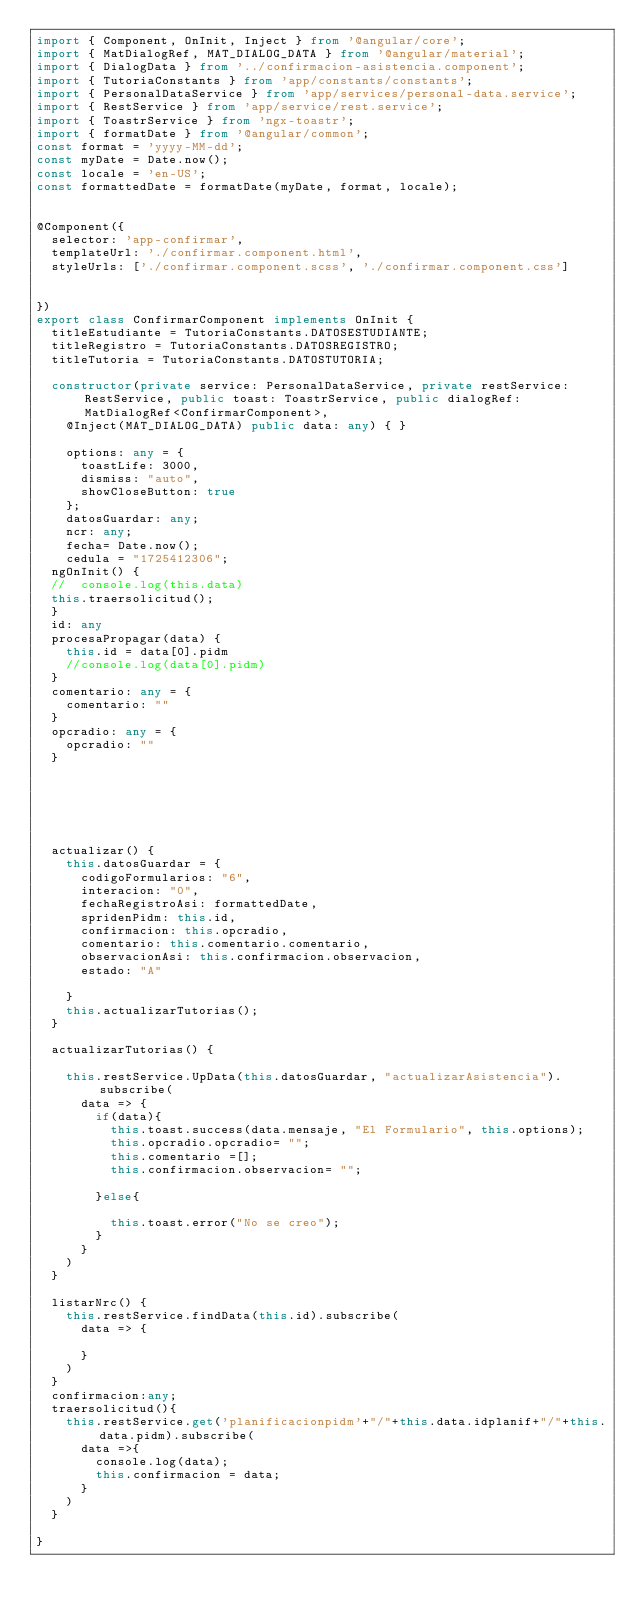Convert code to text. <code><loc_0><loc_0><loc_500><loc_500><_TypeScript_>import { Component, OnInit, Inject } from '@angular/core';
import { MatDialogRef, MAT_DIALOG_DATA } from '@angular/material';
import { DialogData } from '../confirmacion-asistencia.component';
import { TutoriaConstants } from 'app/constants/constants';
import { PersonalDataService } from 'app/services/personal-data.service';
import { RestService } from 'app/service/rest.service';
import { ToastrService } from 'ngx-toastr';
import { formatDate } from '@angular/common';
const format = 'yyyy-MM-dd';
const myDate = Date.now();
const locale = 'en-US';
const formattedDate = formatDate(myDate, format, locale);


@Component({
  selector: 'app-confirmar',
  templateUrl: './confirmar.component.html',
  styleUrls: ['./confirmar.component.scss', './confirmar.component.css']
  

})
export class ConfirmarComponent implements OnInit {
  titleEstudiante = TutoriaConstants.DATOSESTUDIANTE;
  titleRegistro = TutoriaConstants.DATOSREGISTRO;
  titleTutoria = TutoriaConstants.DATOSTUTORIA;

  constructor(private service: PersonalDataService, private restService: RestService, public toast: ToastrService, public dialogRef: MatDialogRef<ConfirmarComponent>,
    @Inject(MAT_DIALOG_DATA) public data: any) { }

    options: any = {
      toastLife: 3000,
      dismiss: "auto",
      showCloseButton: true
    };
    datosGuardar: any;
    ncr: any;
    fecha= Date.now();
    cedula = "1725412306";
  ngOnInit() {
  //  console.log(this.data)
  this.traersolicitud();
  }
  id: any
  procesaPropagar(data) {
    this.id = data[0].pidm
    //console.log(data[0].pidm)
  }
  comentario: any = {
    comentario: ""
  }
  opcradio: any = {
    opcradio: ""
  }



  


  actualizar() {
    this.datosGuardar = {
      codigoFormularios: "6",
      interacion: "0",
      fechaRegistroAsi: formattedDate,
      spridenPidm: this.id,
      confirmacion: this.opcradio,
      comentario: this.comentario.comentario,
      observacionAsi: this.confirmacion.observacion,
      estado: "A"

    }
    this.actualizarTutorias();
  }

  actualizarTutorias() {

    this.restService.UpData(this.datosGuardar, "actualizarAsistencia").subscribe(
      data => {
        if(data){
          this.toast.success(data.mensaje, "El Formulario", this.options);
          this.opcradio.opcradio= "";
          this.comentario =[];
          this.confirmacion.observacion= "";

        }else{

          this.toast.error("No se creo");
        }
      }
    )
  }

  listarNrc() {
    this.restService.findData(this.id).subscribe(
      data => {

      }
    )
  }
  confirmacion:any;
  traersolicitud(){
    this.restService.get('planificacionpidm'+"/"+this.data.idplanif+"/"+this.data.pidm).subscribe(
      data =>{
        console.log(data);
        this.confirmacion = data;
      }
    )
  }

}


</code> 